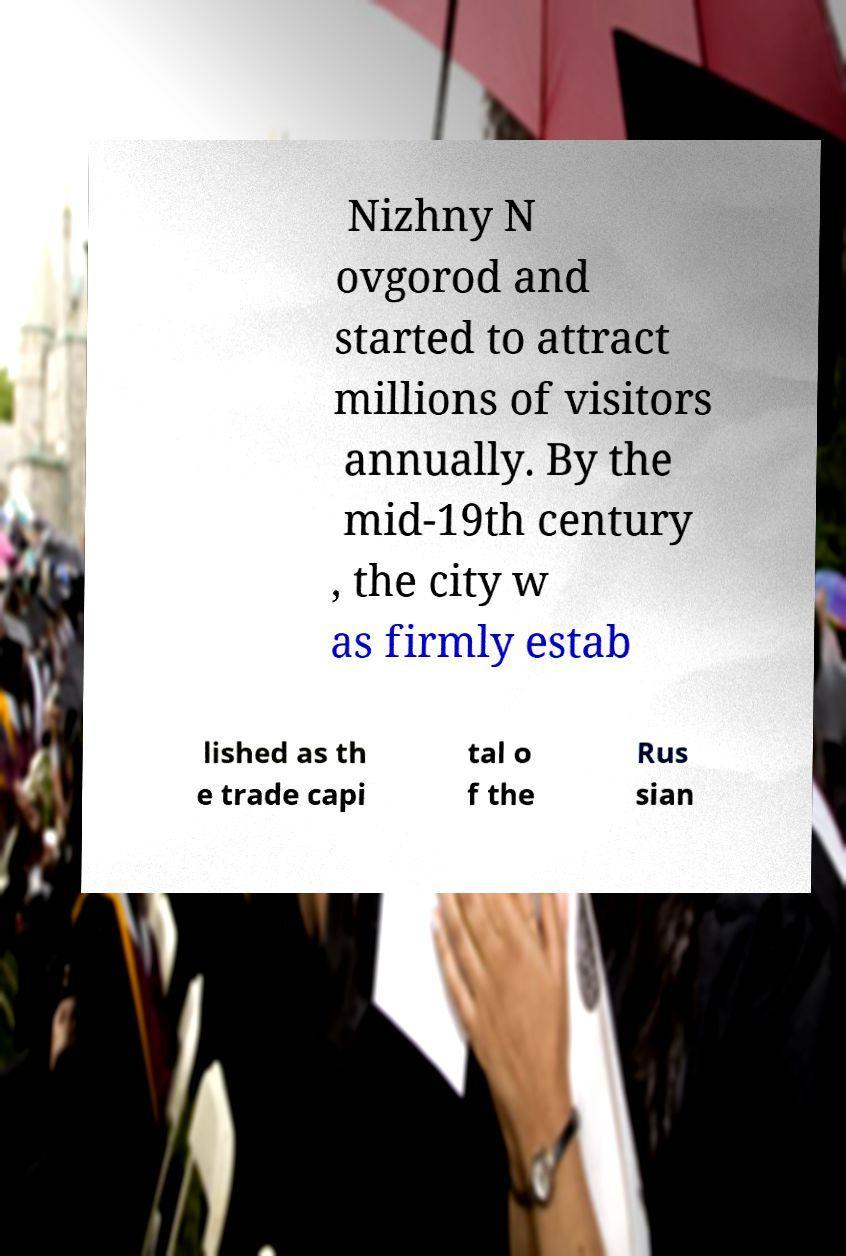Could you assist in decoding the text presented in this image and type it out clearly? Nizhny N ovgorod and started to attract millions of visitors annually. By the mid-19th century , the city w as firmly estab lished as th e trade capi tal o f the Rus sian 